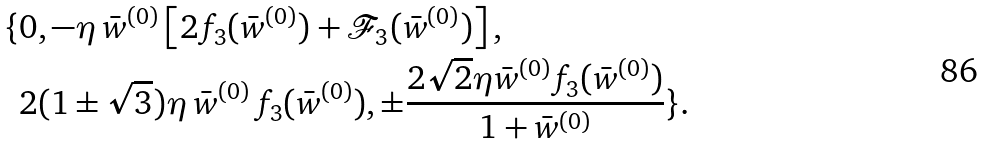Convert formula to latex. <formula><loc_0><loc_0><loc_500><loc_500>\{ & 0 , - \eta \, \bar { w } ^ { ( 0 ) } \left [ 2 f _ { 3 } ( \bar { w } ^ { ( 0 ) } ) + \mathcal { F } _ { 3 } ( \bar { w } ^ { ( 0 ) } ) \right ] , \\ & 2 ( 1 \pm \sqrt { 3 } ) \eta \, \bar { w } ^ { ( 0 ) } \, f _ { 3 } ( \bar { w } ^ { ( 0 ) } ) , \pm \frac { 2 \sqrt { 2 } \eta \bar { w } ^ { ( 0 ) } f _ { 3 } ( \bar { w } ^ { ( 0 ) } ) } { 1 + \bar { w } ^ { ( 0 ) } } \} .</formula> 